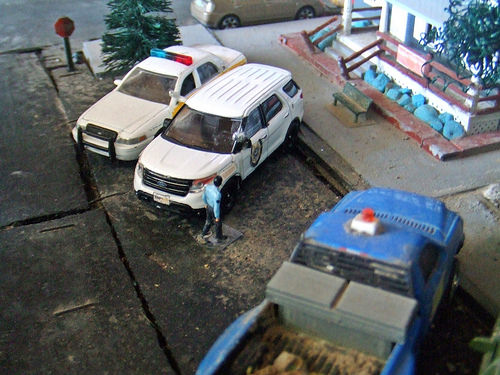<image>
Is the lights to the left of the bench? Yes. From this viewpoint, the lights is positioned to the left side relative to the bench. Is there a police car behind the figure? Yes. From this viewpoint, the police car is positioned behind the figure, with the figure partially or fully occluding the police car. Is the car behind the car? No. The car is not behind the car. From this viewpoint, the car appears to be positioned elsewhere in the scene. 